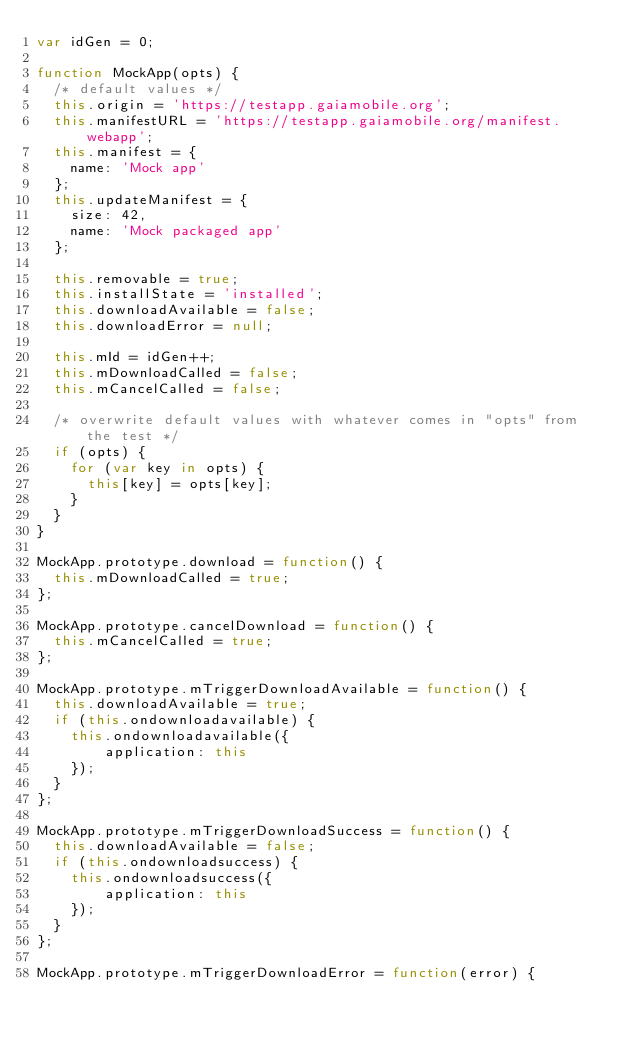<code> <loc_0><loc_0><loc_500><loc_500><_JavaScript_>var idGen = 0;

function MockApp(opts) {
  /* default values */
  this.origin = 'https://testapp.gaiamobile.org';
  this.manifestURL = 'https://testapp.gaiamobile.org/manifest.webapp';
  this.manifest = {
    name: 'Mock app'
  };
  this.updateManifest = {
    size: 42,
    name: 'Mock packaged app'
  };

  this.removable = true;
  this.installState = 'installed';
  this.downloadAvailable = false;
  this.downloadError = null;

  this.mId = idGen++;
  this.mDownloadCalled = false;
  this.mCancelCalled = false;

  /* overwrite default values with whatever comes in "opts" from the test */
  if (opts) {
    for (var key in opts) {
      this[key] = opts[key];
    }
  }
}

MockApp.prototype.download = function() {
  this.mDownloadCalled = true;
};

MockApp.prototype.cancelDownload = function() {
  this.mCancelCalled = true;
};

MockApp.prototype.mTriggerDownloadAvailable = function() {
  this.downloadAvailable = true;
  if (this.ondownloadavailable) {
    this.ondownloadavailable({
        application: this
    });
  }
};

MockApp.prototype.mTriggerDownloadSuccess = function() {
  this.downloadAvailable = false;
  if (this.ondownloadsuccess) {
    this.ondownloadsuccess({
        application: this
    });
  }
};

MockApp.prototype.mTriggerDownloadError = function(error) {</code> 